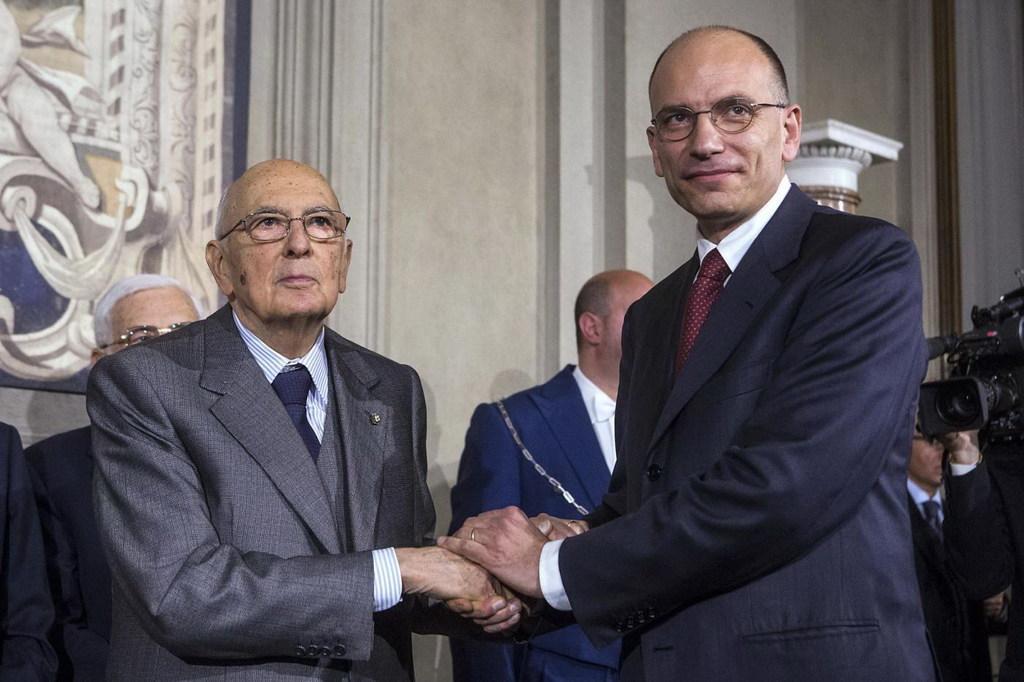How would you summarize this image in a sentence or two? In this picture there are two people standing and holding the hands. At the back there are group of people standing and there is a man holding the camera and there is a pillar and there might be a board on the wall. 